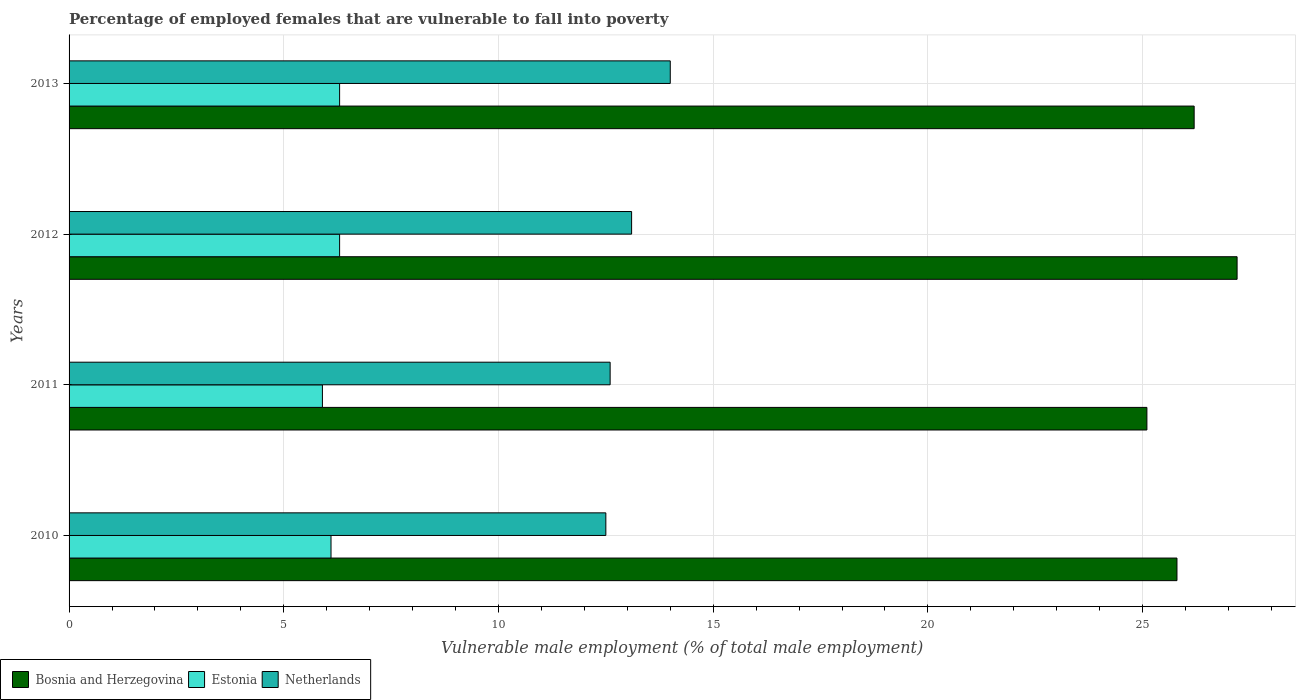How many different coloured bars are there?
Ensure brevity in your answer.  3. Are the number of bars per tick equal to the number of legend labels?
Your response must be concise. Yes. Are the number of bars on each tick of the Y-axis equal?
Keep it short and to the point. Yes. How many bars are there on the 2nd tick from the top?
Your answer should be compact. 3. How many bars are there on the 3rd tick from the bottom?
Keep it short and to the point. 3. What is the label of the 4th group of bars from the top?
Your response must be concise. 2010. What is the percentage of employed females who are vulnerable to fall into poverty in Estonia in 2011?
Your answer should be compact. 5.9. Across all years, what is the minimum percentage of employed females who are vulnerable to fall into poverty in Estonia?
Provide a succinct answer. 5.9. What is the total percentage of employed females who are vulnerable to fall into poverty in Bosnia and Herzegovina in the graph?
Your answer should be compact. 104.3. What is the difference between the percentage of employed females who are vulnerable to fall into poverty in Estonia in 2011 and that in 2012?
Make the answer very short. -0.4. What is the difference between the percentage of employed females who are vulnerable to fall into poverty in Netherlands in 2010 and the percentage of employed females who are vulnerable to fall into poverty in Bosnia and Herzegovina in 2012?
Provide a short and direct response. -14.7. What is the average percentage of employed females who are vulnerable to fall into poverty in Estonia per year?
Provide a succinct answer. 6.15. In the year 2013, what is the difference between the percentage of employed females who are vulnerable to fall into poverty in Netherlands and percentage of employed females who are vulnerable to fall into poverty in Estonia?
Offer a very short reply. 7.7. In how many years, is the percentage of employed females who are vulnerable to fall into poverty in Estonia greater than 3 %?
Ensure brevity in your answer.  4. What is the ratio of the percentage of employed females who are vulnerable to fall into poverty in Netherlands in 2011 to that in 2013?
Offer a terse response. 0.9. Is the percentage of employed females who are vulnerable to fall into poverty in Estonia in 2011 less than that in 2012?
Offer a very short reply. Yes. Is the difference between the percentage of employed females who are vulnerable to fall into poverty in Netherlands in 2011 and 2013 greater than the difference between the percentage of employed females who are vulnerable to fall into poverty in Estonia in 2011 and 2013?
Your response must be concise. No. What is the difference between the highest and the second highest percentage of employed females who are vulnerable to fall into poverty in Bosnia and Herzegovina?
Provide a succinct answer. 1. What is the difference between the highest and the lowest percentage of employed females who are vulnerable to fall into poverty in Bosnia and Herzegovina?
Your answer should be compact. 2.1. What does the 3rd bar from the top in 2012 represents?
Your answer should be compact. Bosnia and Herzegovina. What does the 2nd bar from the bottom in 2012 represents?
Make the answer very short. Estonia. Is it the case that in every year, the sum of the percentage of employed females who are vulnerable to fall into poverty in Bosnia and Herzegovina and percentage of employed females who are vulnerable to fall into poverty in Estonia is greater than the percentage of employed females who are vulnerable to fall into poverty in Netherlands?
Keep it short and to the point. Yes. Are all the bars in the graph horizontal?
Your answer should be compact. Yes. How many years are there in the graph?
Provide a succinct answer. 4. Are the values on the major ticks of X-axis written in scientific E-notation?
Give a very brief answer. No. How many legend labels are there?
Your answer should be compact. 3. How are the legend labels stacked?
Your answer should be very brief. Horizontal. What is the title of the graph?
Your answer should be compact. Percentage of employed females that are vulnerable to fall into poverty. Does "Macedonia" appear as one of the legend labels in the graph?
Give a very brief answer. No. What is the label or title of the X-axis?
Provide a succinct answer. Vulnerable male employment (% of total male employment). What is the Vulnerable male employment (% of total male employment) of Bosnia and Herzegovina in 2010?
Your response must be concise. 25.8. What is the Vulnerable male employment (% of total male employment) in Estonia in 2010?
Your answer should be very brief. 6.1. What is the Vulnerable male employment (% of total male employment) in Bosnia and Herzegovina in 2011?
Your answer should be very brief. 25.1. What is the Vulnerable male employment (% of total male employment) of Estonia in 2011?
Ensure brevity in your answer.  5.9. What is the Vulnerable male employment (% of total male employment) in Netherlands in 2011?
Give a very brief answer. 12.6. What is the Vulnerable male employment (% of total male employment) in Bosnia and Herzegovina in 2012?
Provide a succinct answer. 27.2. What is the Vulnerable male employment (% of total male employment) in Estonia in 2012?
Your answer should be compact. 6.3. What is the Vulnerable male employment (% of total male employment) of Netherlands in 2012?
Your answer should be compact. 13.1. What is the Vulnerable male employment (% of total male employment) in Bosnia and Herzegovina in 2013?
Keep it short and to the point. 26.2. What is the Vulnerable male employment (% of total male employment) in Estonia in 2013?
Your response must be concise. 6.3. Across all years, what is the maximum Vulnerable male employment (% of total male employment) in Bosnia and Herzegovina?
Your response must be concise. 27.2. Across all years, what is the maximum Vulnerable male employment (% of total male employment) in Estonia?
Your response must be concise. 6.3. Across all years, what is the maximum Vulnerable male employment (% of total male employment) in Netherlands?
Your answer should be compact. 14. Across all years, what is the minimum Vulnerable male employment (% of total male employment) of Bosnia and Herzegovina?
Offer a very short reply. 25.1. Across all years, what is the minimum Vulnerable male employment (% of total male employment) of Estonia?
Ensure brevity in your answer.  5.9. Across all years, what is the minimum Vulnerable male employment (% of total male employment) of Netherlands?
Offer a very short reply. 12.5. What is the total Vulnerable male employment (% of total male employment) in Bosnia and Herzegovina in the graph?
Give a very brief answer. 104.3. What is the total Vulnerable male employment (% of total male employment) of Estonia in the graph?
Your response must be concise. 24.6. What is the total Vulnerable male employment (% of total male employment) of Netherlands in the graph?
Offer a very short reply. 52.2. What is the difference between the Vulnerable male employment (% of total male employment) in Bosnia and Herzegovina in 2010 and that in 2011?
Make the answer very short. 0.7. What is the difference between the Vulnerable male employment (% of total male employment) of Estonia in 2010 and that in 2011?
Provide a succinct answer. 0.2. What is the difference between the Vulnerable male employment (% of total male employment) of Netherlands in 2010 and that in 2011?
Your answer should be compact. -0.1. What is the difference between the Vulnerable male employment (% of total male employment) in Bosnia and Herzegovina in 2010 and that in 2012?
Your answer should be compact. -1.4. What is the difference between the Vulnerable male employment (% of total male employment) in Estonia in 2010 and that in 2012?
Your answer should be very brief. -0.2. What is the difference between the Vulnerable male employment (% of total male employment) in Bosnia and Herzegovina in 2010 and that in 2013?
Your answer should be very brief. -0.4. What is the difference between the Vulnerable male employment (% of total male employment) in Bosnia and Herzegovina in 2011 and that in 2012?
Your answer should be compact. -2.1. What is the difference between the Vulnerable male employment (% of total male employment) of Netherlands in 2011 and that in 2012?
Make the answer very short. -0.5. What is the difference between the Vulnerable male employment (% of total male employment) in Bosnia and Herzegovina in 2011 and that in 2013?
Your answer should be compact. -1.1. What is the difference between the Vulnerable male employment (% of total male employment) in Estonia in 2011 and that in 2013?
Provide a succinct answer. -0.4. What is the difference between the Vulnerable male employment (% of total male employment) in Bosnia and Herzegovina in 2012 and that in 2013?
Make the answer very short. 1. What is the difference between the Vulnerable male employment (% of total male employment) in Netherlands in 2012 and that in 2013?
Your response must be concise. -0.9. What is the difference between the Vulnerable male employment (% of total male employment) in Bosnia and Herzegovina in 2010 and the Vulnerable male employment (% of total male employment) in Estonia in 2011?
Provide a succinct answer. 19.9. What is the difference between the Vulnerable male employment (% of total male employment) in Bosnia and Herzegovina in 2010 and the Vulnerable male employment (% of total male employment) in Netherlands in 2011?
Provide a succinct answer. 13.2. What is the difference between the Vulnerable male employment (% of total male employment) of Estonia in 2010 and the Vulnerable male employment (% of total male employment) of Netherlands in 2012?
Give a very brief answer. -7. What is the difference between the Vulnerable male employment (% of total male employment) in Estonia in 2010 and the Vulnerable male employment (% of total male employment) in Netherlands in 2013?
Make the answer very short. -7.9. What is the difference between the Vulnerable male employment (% of total male employment) in Bosnia and Herzegovina in 2011 and the Vulnerable male employment (% of total male employment) in Estonia in 2012?
Provide a succinct answer. 18.8. What is the difference between the Vulnerable male employment (% of total male employment) of Bosnia and Herzegovina in 2011 and the Vulnerable male employment (% of total male employment) of Netherlands in 2012?
Offer a very short reply. 12. What is the difference between the Vulnerable male employment (% of total male employment) in Estonia in 2011 and the Vulnerable male employment (% of total male employment) in Netherlands in 2012?
Make the answer very short. -7.2. What is the difference between the Vulnerable male employment (% of total male employment) of Bosnia and Herzegovina in 2011 and the Vulnerable male employment (% of total male employment) of Netherlands in 2013?
Give a very brief answer. 11.1. What is the difference between the Vulnerable male employment (% of total male employment) of Bosnia and Herzegovina in 2012 and the Vulnerable male employment (% of total male employment) of Estonia in 2013?
Your response must be concise. 20.9. What is the average Vulnerable male employment (% of total male employment) of Bosnia and Herzegovina per year?
Your response must be concise. 26.07. What is the average Vulnerable male employment (% of total male employment) in Estonia per year?
Your answer should be very brief. 6.15. What is the average Vulnerable male employment (% of total male employment) in Netherlands per year?
Your answer should be very brief. 13.05. In the year 2010, what is the difference between the Vulnerable male employment (% of total male employment) of Bosnia and Herzegovina and Vulnerable male employment (% of total male employment) of Netherlands?
Keep it short and to the point. 13.3. In the year 2010, what is the difference between the Vulnerable male employment (% of total male employment) of Estonia and Vulnerable male employment (% of total male employment) of Netherlands?
Give a very brief answer. -6.4. In the year 2011, what is the difference between the Vulnerable male employment (% of total male employment) in Bosnia and Herzegovina and Vulnerable male employment (% of total male employment) in Netherlands?
Offer a terse response. 12.5. In the year 2012, what is the difference between the Vulnerable male employment (% of total male employment) of Bosnia and Herzegovina and Vulnerable male employment (% of total male employment) of Estonia?
Your response must be concise. 20.9. In the year 2012, what is the difference between the Vulnerable male employment (% of total male employment) in Bosnia and Herzegovina and Vulnerable male employment (% of total male employment) in Netherlands?
Offer a terse response. 14.1. In the year 2012, what is the difference between the Vulnerable male employment (% of total male employment) in Estonia and Vulnerable male employment (% of total male employment) in Netherlands?
Make the answer very short. -6.8. In the year 2013, what is the difference between the Vulnerable male employment (% of total male employment) of Bosnia and Herzegovina and Vulnerable male employment (% of total male employment) of Estonia?
Keep it short and to the point. 19.9. In the year 2013, what is the difference between the Vulnerable male employment (% of total male employment) of Estonia and Vulnerable male employment (% of total male employment) of Netherlands?
Make the answer very short. -7.7. What is the ratio of the Vulnerable male employment (% of total male employment) of Bosnia and Herzegovina in 2010 to that in 2011?
Offer a terse response. 1.03. What is the ratio of the Vulnerable male employment (% of total male employment) in Estonia in 2010 to that in 2011?
Offer a terse response. 1.03. What is the ratio of the Vulnerable male employment (% of total male employment) in Netherlands in 2010 to that in 2011?
Give a very brief answer. 0.99. What is the ratio of the Vulnerable male employment (% of total male employment) in Bosnia and Herzegovina in 2010 to that in 2012?
Your answer should be compact. 0.95. What is the ratio of the Vulnerable male employment (% of total male employment) of Estonia in 2010 to that in 2012?
Make the answer very short. 0.97. What is the ratio of the Vulnerable male employment (% of total male employment) of Netherlands in 2010 to that in 2012?
Provide a short and direct response. 0.95. What is the ratio of the Vulnerable male employment (% of total male employment) in Bosnia and Herzegovina in 2010 to that in 2013?
Your answer should be compact. 0.98. What is the ratio of the Vulnerable male employment (% of total male employment) in Estonia in 2010 to that in 2013?
Make the answer very short. 0.97. What is the ratio of the Vulnerable male employment (% of total male employment) of Netherlands in 2010 to that in 2013?
Give a very brief answer. 0.89. What is the ratio of the Vulnerable male employment (% of total male employment) in Bosnia and Herzegovina in 2011 to that in 2012?
Your answer should be compact. 0.92. What is the ratio of the Vulnerable male employment (% of total male employment) in Estonia in 2011 to that in 2012?
Your answer should be compact. 0.94. What is the ratio of the Vulnerable male employment (% of total male employment) of Netherlands in 2011 to that in 2012?
Ensure brevity in your answer.  0.96. What is the ratio of the Vulnerable male employment (% of total male employment) of Bosnia and Herzegovina in 2011 to that in 2013?
Make the answer very short. 0.96. What is the ratio of the Vulnerable male employment (% of total male employment) in Estonia in 2011 to that in 2013?
Keep it short and to the point. 0.94. What is the ratio of the Vulnerable male employment (% of total male employment) of Netherlands in 2011 to that in 2013?
Offer a very short reply. 0.9. What is the ratio of the Vulnerable male employment (% of total male employment) in Bosnia and Herzegovina in 2012 to that in 2013?
Your answer should be very brief. 1.04. What is the ratio of the Vulnerable male employment (% of total male employment) of Estonia in 2012 to that in 2013?
Keep it short and to the point. 1. What is the ratio of the Vulnerable male employment (% of total male employment) in Netherlands in 2012 to that in 2013?
Your answer should be compact. 0.94. What is the difference between the highest and the second highest Vulnerable male employment (% of total male employment) in Bosnia and Herzegovina?
Your answer should be compact. 1. What is the difference between the highest and the lowest Vulnerable male employment (% of total male employment) of Bosnia and Herzegovina?
Your answer should be very brief. 2.1. What is the difference between the highest and the lowest Vulnerable male employment (% of total male employment) in Estonia?
Your answer should be compact. 0.4. What is the difference between the highest and the lowest Vulnerable male employment (% of total male employment) of Netherlands?
Your answer should be very brief. 1.5. 